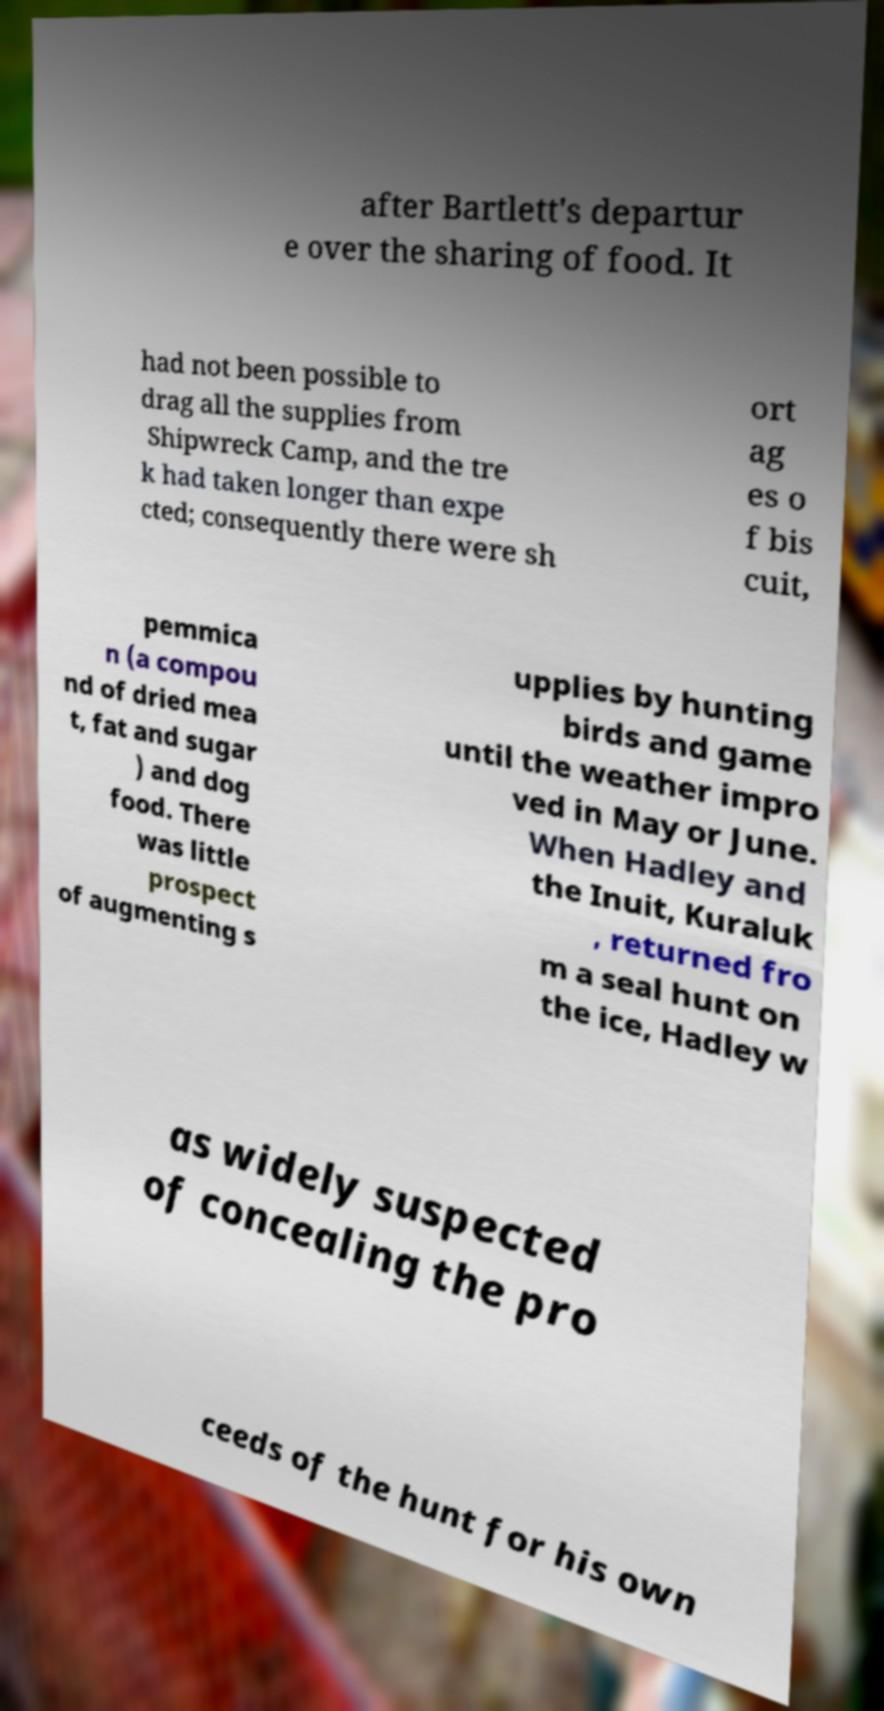What messages or text are displayed in this image? I need them in a readable, typed format. after Bartlett's departur e over the sharing of food. It had not been possible to drag all the supplies from Shipwreck Camp, and the tre k had taken longer than expe cted; consequently there were sh ort ag es o f bis cuit, pemmica n (a compou nd of dried mea t, fat and sugar ) and dog food. There was little prospect of augmenting s upplies by hunting birds and game until the weather impro ved in May or June. When Hadley and the Inuit, Kuraluk , returned fro m a seal hunt on the ice, Hadley w as widely suspected of concealing the pro ceeds of the hunt for his own 